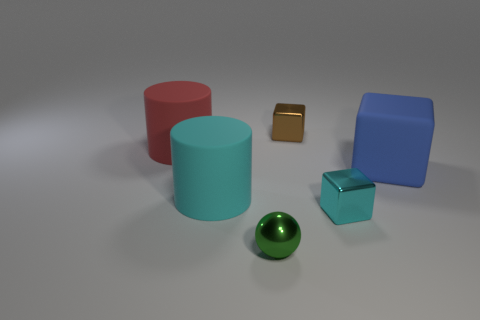Add 1 large metal cylinders. How many objects exist? 7 Subtract all tiny brown cubes. How many cubes are left? 2 Subtract all balls. How many objects are left? 5 Subtract all gray blocks. Subtract all red cylinders. How many blocks are left? 3 Add 3 gray rubber things. How many gray rubber things exist? 3 Subtract 0 green blocks. How many objects are left? 6 Subtract all tiny blue metal cylinders. Subtract all tiny brown objects. How many objects are left? 5 Add 6 cylinders. How many cylinders are left? 8 